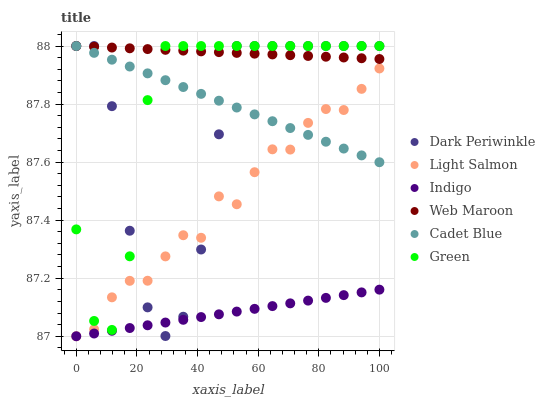Does Indigo have the minimum area under the curve?
Answer yes or no. Yes. Does Web Maroon have the maximum area under the curve?
Answer yes or no. Yes. Does Cadet Blue have the minimum area under the curve?
Answer yes or no. No. Does Cadet Blue have the maximum area under the curve?
Answer yes or no. No. Is Cadet Blue the smoothest?
Answer yes or no. Yes. Is Dark Periwinkle the roughest?
Answer yes or no. Yes. Is Indigo the smoothest?
Answer yes or no. No. Is Indigo the roughest?
Answer yes or no. No. Does Light Salmon have the lowest value?
Answer yes or no. Yes. Does Cadet Blue have the lowest value?
Answer yes or no. No. Does Dark Periwinkle have the highest value?
Answer yes or no. Yes. Does Indigo have the highest value?
Answer yes or no. No. Is Light Salmon less than Web Maroon?
Answer yes or no. Yes. Is Green greater than Indigo?
Answer yes or no. Yes. Does Dark Periwinkle intersect Cadet Blue?
Answer yes or no. Yes. Is Dark Periwinkle less than Cadet Blue?
Answer yes or no. No. Is Dark Periwinkle greater than Cadet Blue?
Answer yes or no. No. Does Light Salmon intersect Web Maroon?
Answer yes or no. No. 